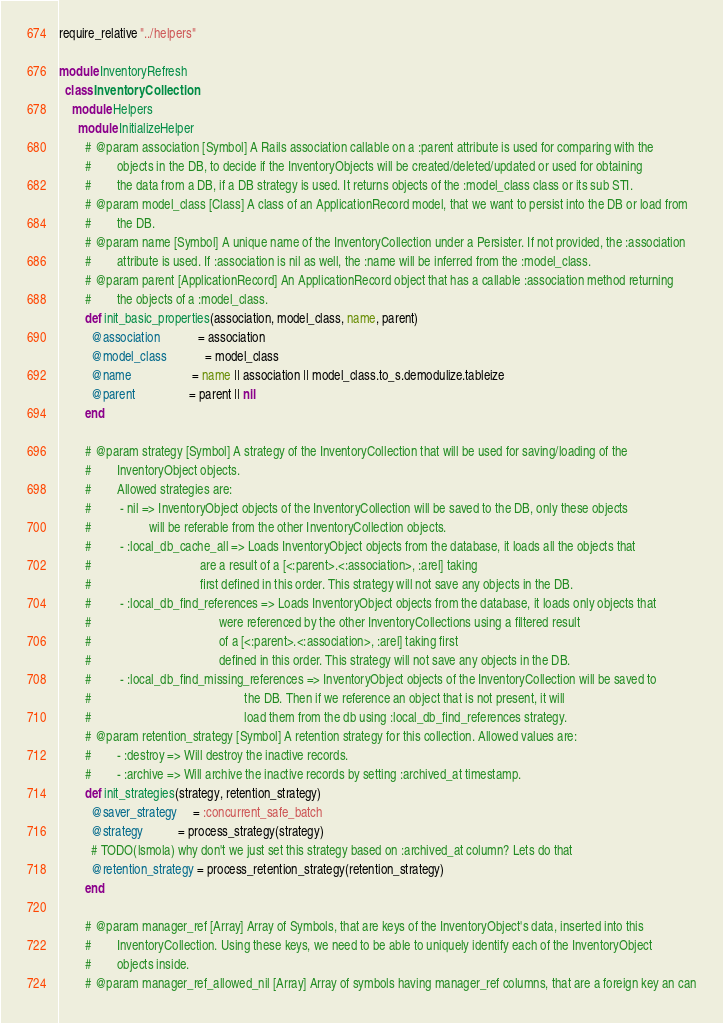<code> <loc_0><loc_0><loc_500><loc_500><_Ruby_>require_relative "../helpers"

module InventoryRefresh
  class InventoryCollection
    module Helpers
      module InitializeHelper
        # @param association [Symbol] A Rails association callable on a :parent attribute is used for comparing with the
        #        objects in the DB, to decide if the InventoryObjects will be created/deleted/updated or used for obtaining
        #        the data from a DB, if a DB strategy is used. It returns objects of the :model_class class or its sub STI.
        # @param model_class [Class] A class of an ApplicationRecord model, that we want to persist into the DB or load from
        #        the DB.
        # @param name [Symbol] A unique name of the InventoryCollection under a Persister. If not provided, the :association
        #        attribute is used. If :association is nil as well, the :name will be inferred from the :model_class.
        # @param parent [ApplicationRecord] An ApplicationRecord object that has a callable :association method returning
        #        the objects of a :model_class.
        def init_basic_properties(association, model_class, name, parent)
          @association            = association
          @model_class            = model_class
          @name                   = name || association || model_class.to_s.demodulize.tableize
          @parent                 = parent || nil
        end

        # @param strategy [Symbol] A strategy of the InventoryCollection that will be used for saving/loading of the
        #        InventoryObject objects.
        #        Allowed strategies are:
        #         - nil => InventoryObject objects of the InventoryCollection will be saved to the DB, only these objects
        #                  will be referable from the other InventoryCollection objects.
        #         - :local_db_cache_all => Loads InventoryObject objects from the database, it loads all the objects that
        #                                  are a result of a [<:parent>.<:association>, :arel] taking
        #                                  first defined in this order. This strategy will not save any objects in the DB.
        #         - :local_db_find_references => Loads InventoryObject objects from the database, it loads only objects that
        #                                        were referenced by the other InventoryCollections using a filtered result
        #                                        of a [<:parent>.<:association>, :arel] taking first
        #                                        defined in this order. This strategy will not save any objects in the DB.
        #         - :local_db_find_missing_references => InventoryObject objects of the InventoryCollection will be saved to
        #                                                the DB. Then if we reference an object that is not present, it will
        #                                                load them from the db using :local_db_find_references strategy.
        # @param retention_strategy [Symbol] A retention strategy for this collection. Allowed values are:
        #        - :destroy => Will destroy the inactive records.
        #        - :archive => Will archive the inactive records by setting :archived_at timestamp.
        def init_strategies(strategy, retention_strategy)
          @saver_strategy     = :concurrent_safe_batch
          @strategy           = process_strategy(strategy)
          # TODO(lsmola) why don't we just set this strategy based on :archived_at column? Lets do that
          @retention_strategy = process_retention_strategy(retention_strategy)
        end

        # @param manager_ref [Array] Array of Symbols, that are keys of the InventoryObject's data, inserted into this
        #        InventoryCollection. Using these keys, we need to be able to uniquely identify each of the InventoryObject
        #        objects inside.
        # @param manager_ref_allowed_nil [Array] Array of symbols having manager_ref columns, that are a foreign key an can</code> 